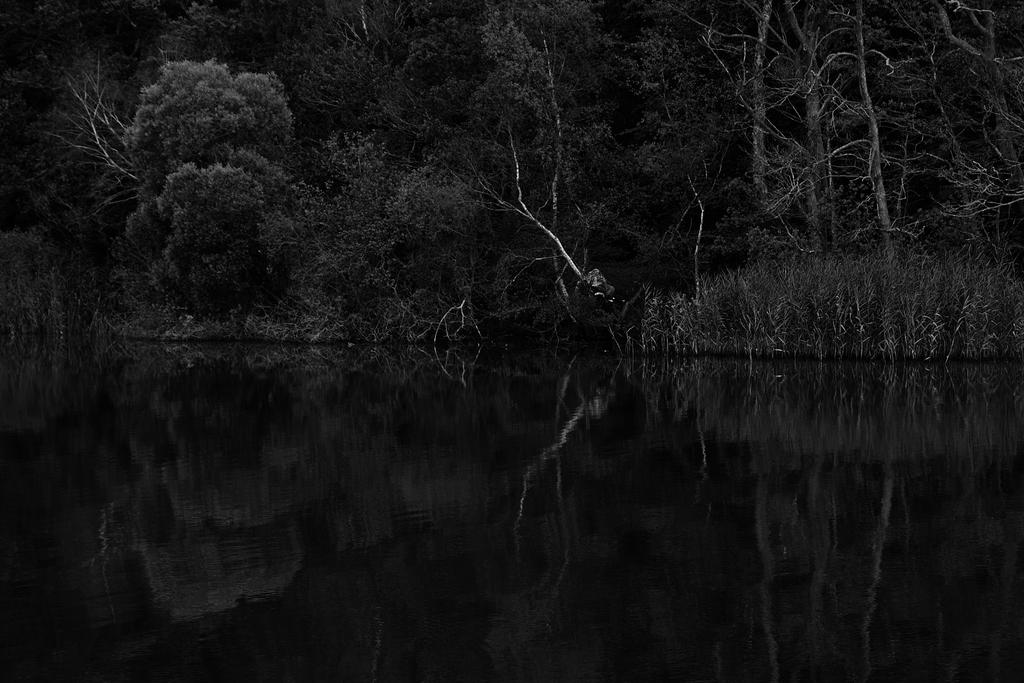What is the color scheme of the image? The image is black and white. What can be seen at the bottom of the image? There is water at the bottom of the image. What type of vegetation is present in the image? There are trees in the middle of the image. How many houses are visible in the image? There are no houses present in the image; it features water and trees. What type of toy can be seen floating in the water in the image? There is no toy present in the image; it only features water and trees. 